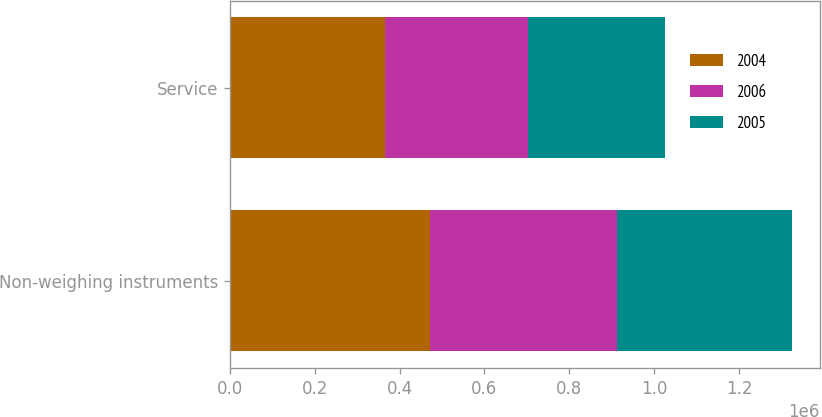<chart> <loc_0><loc_0><loc_500><loc_500><stacked_bar_chart><ecel><fcel>Non-weighing instruments<fcel>Service<nl><fcel>2004<fcel>471478<fcel>364552<nl><fcel>2006<fcel>440728<fcel>338163<nl><fcel>2005<fcel>412086<fcel>322357<nl></chart> 